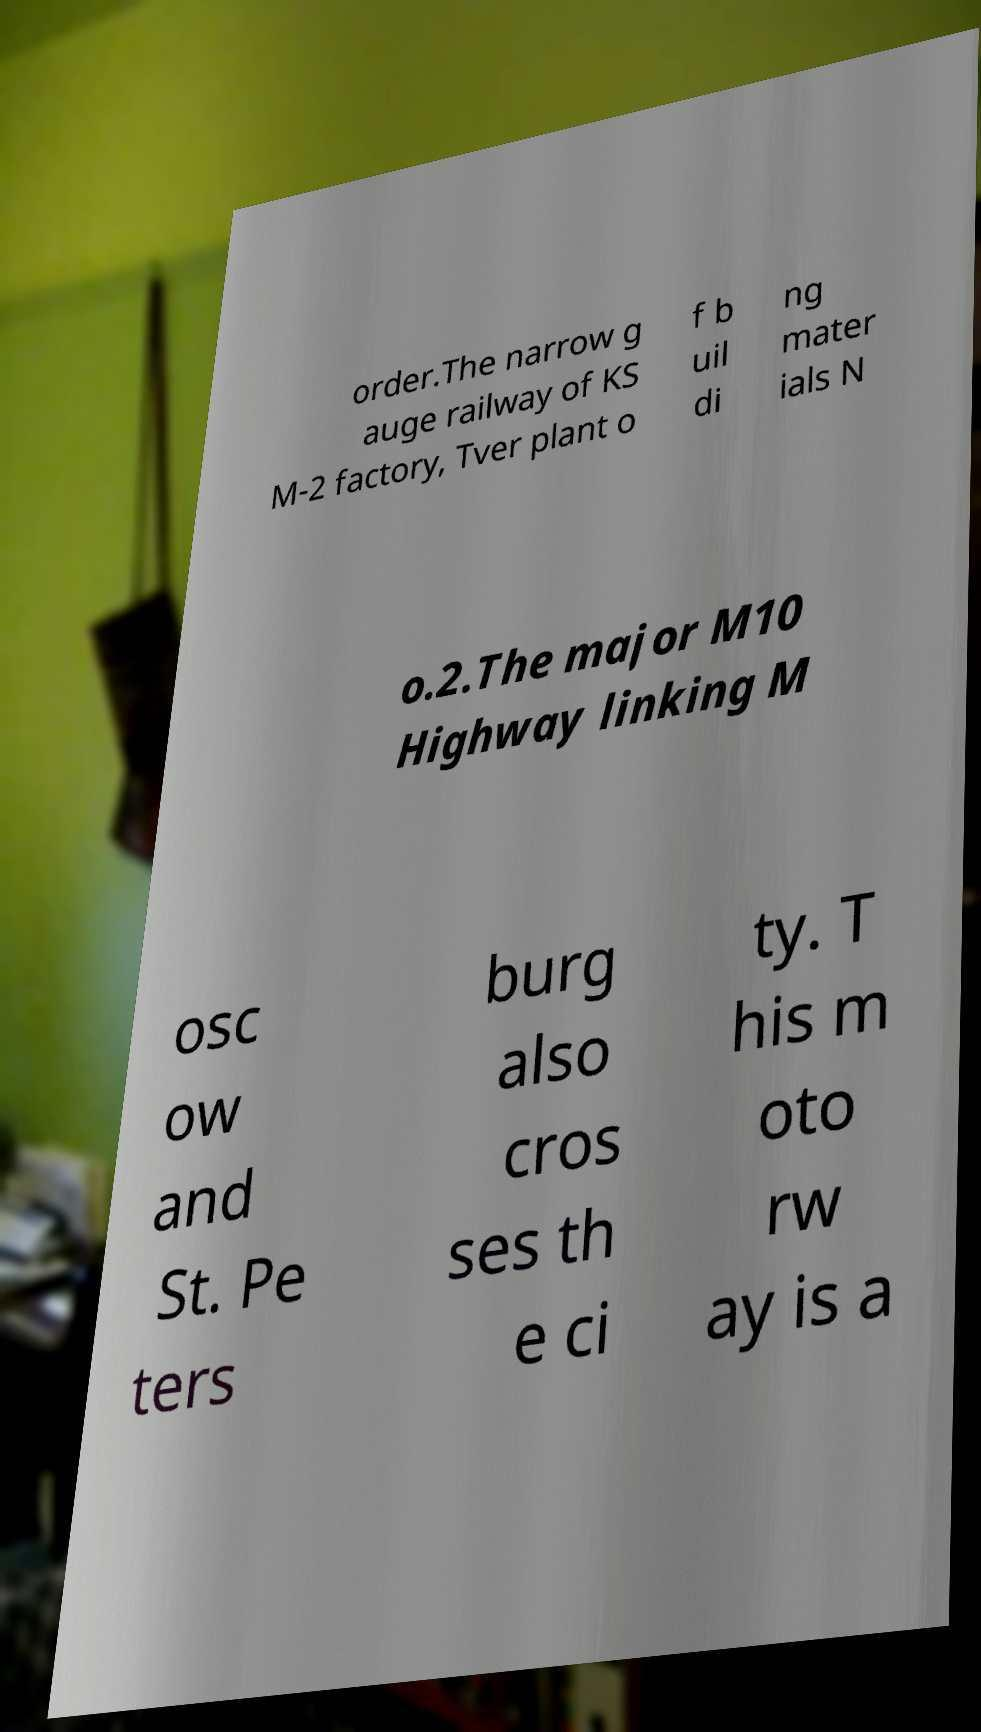Please read and relay the text visible in this image. What does it say? order.The narrow g auge railway of KS M-2 factory, Tver plant o f b uil di ng mater ials N o.2.The major M10 Highway linking M osc ow and St. Pe ters burg also cros ses th e ci ty. T his m oto rw ay is a 